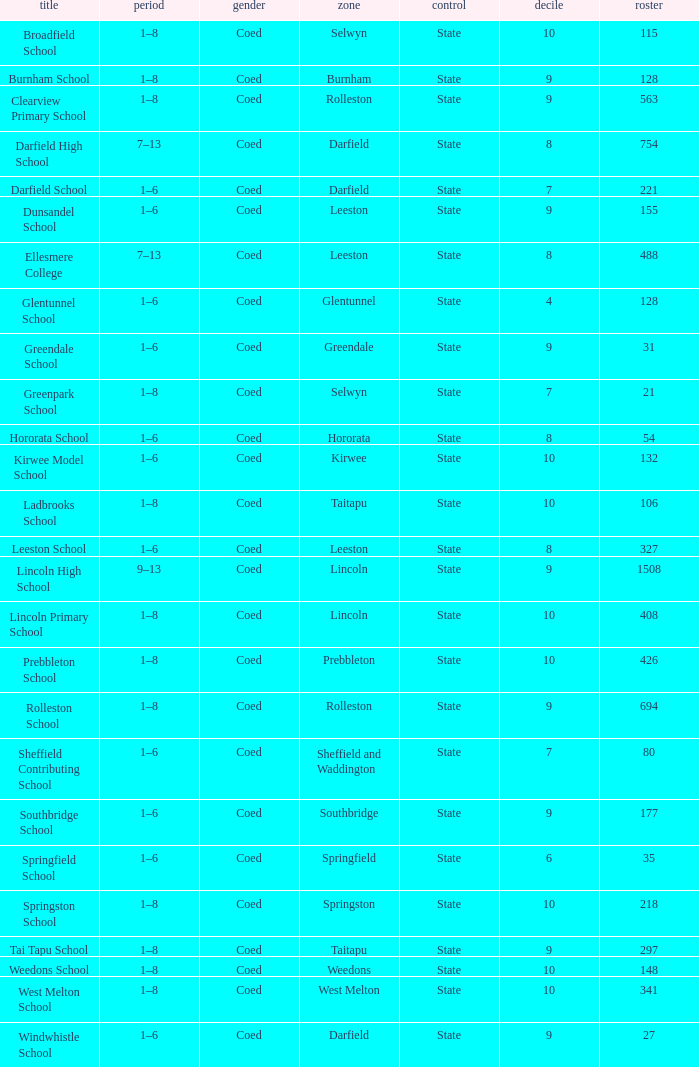Which area has a Decile of 9, and a Roll of 31? Greendale. 